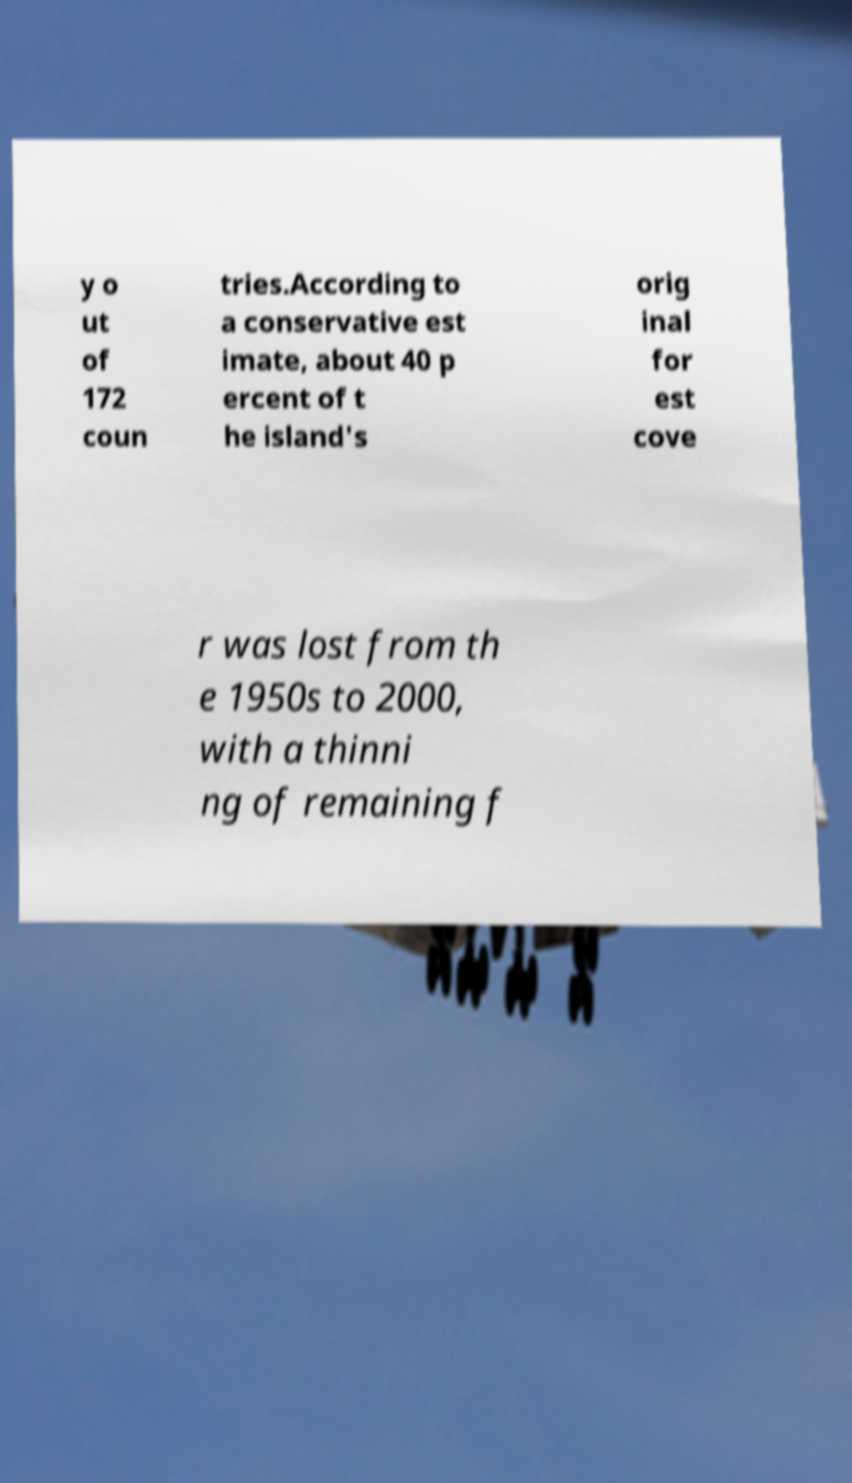I need the written content from this picture converted into text. Can you do that? y o ut of 172 coun tries.According to a conservative est imate, about 40 p ercent of t he island's orig inal for est cove r was lost from th e 1950s to 2000, with a thinni ng of remaining f 